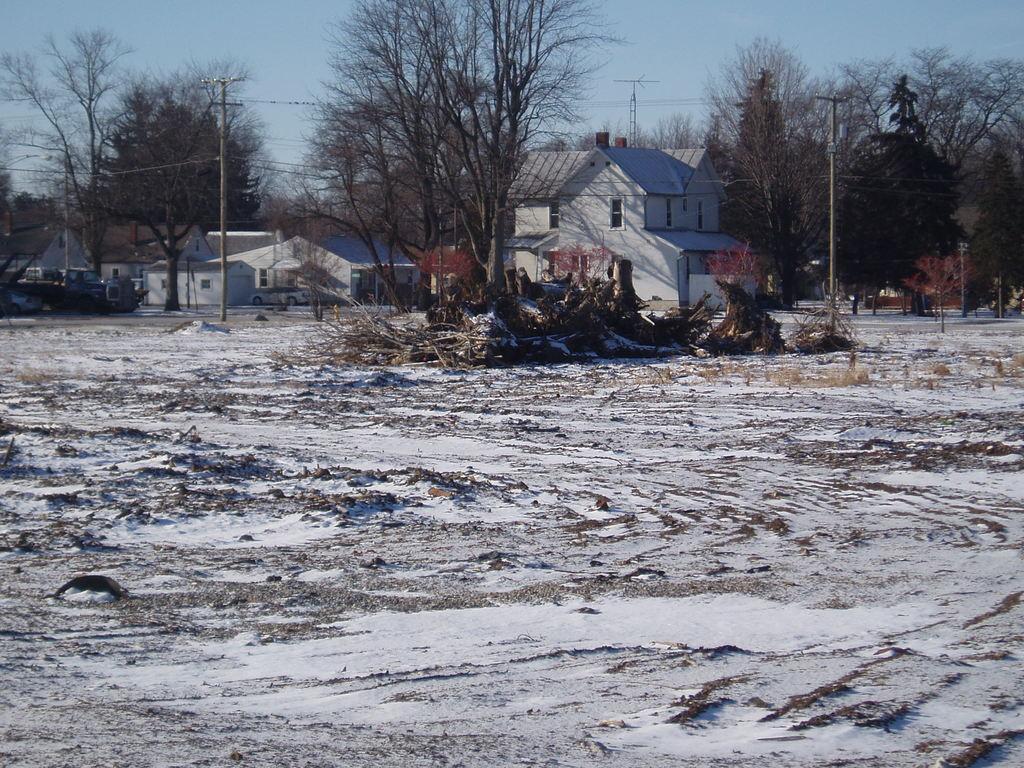Could you give a brief overview of what you see in this image? In this image, we can see trees, houses, vehicle, plants, poles, group of twigs. At the bottom, we can see snow on the ground. Background there is a sky. 